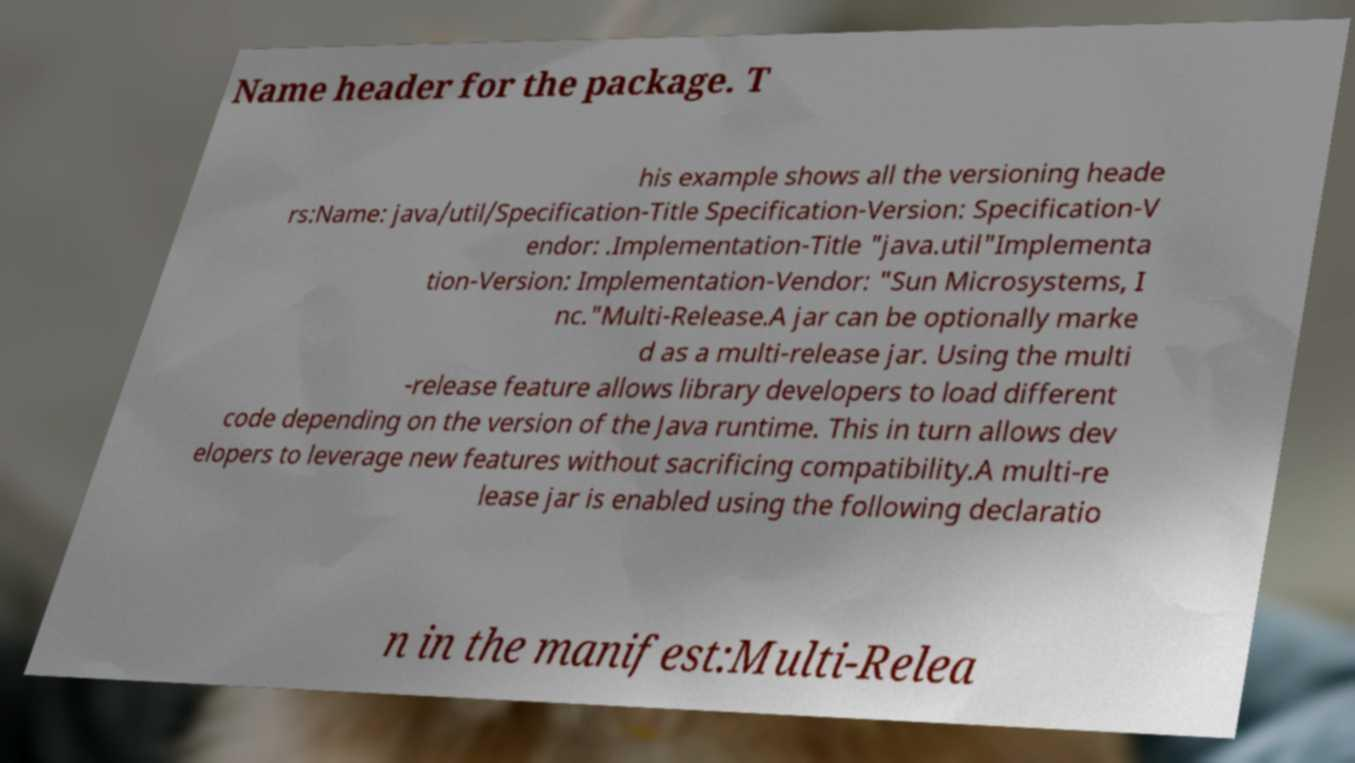Please identify and transcribe the text found in this image. Name header for the package. T his example shows all the versioning heade rs:Name: java/util/Specification-Title Specification-Version: Specification-V endor: .Implementation-Title "java.util"Implementa tion-Version: Implementation-Vendor: "Sun Microsystems, I nc."Multi-Release.A jar can be optionally marke d as a multi-release jar. Using the multi -release feature allows library developers to load different code depending on the version of the Java runtime. This in turn allows dev elopers to leverage new features without sacrificing compatibility.A multi-re lease jar is enabled using the following declaratio n in the manifest:Multi-Relea 